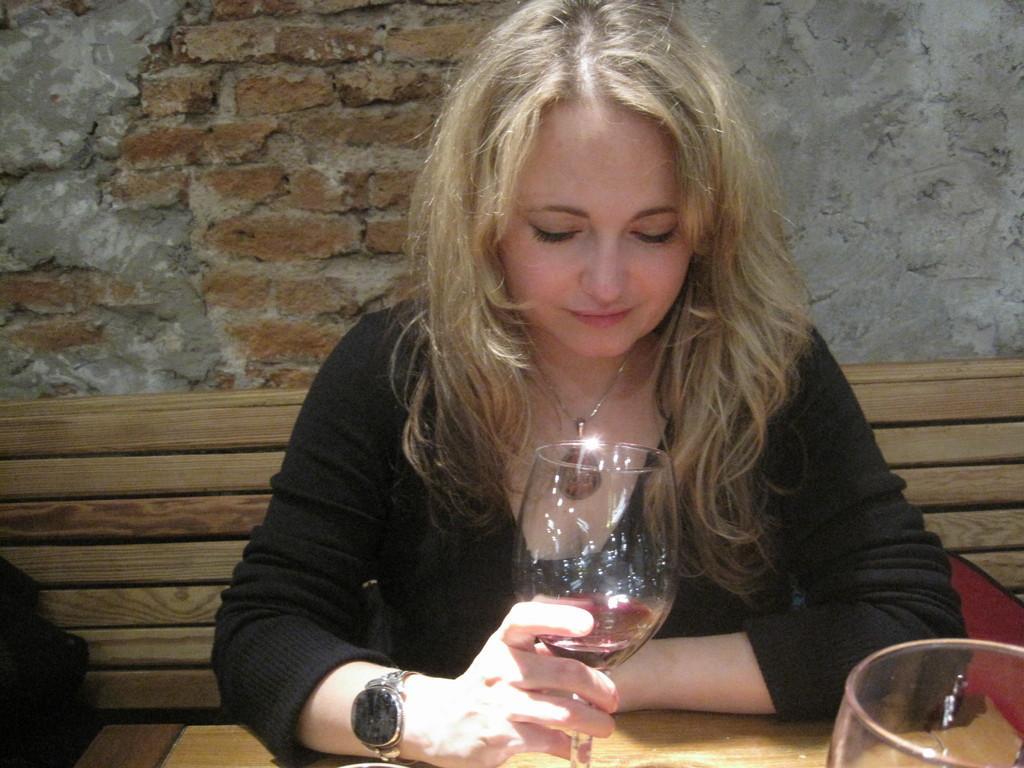In one or two sentences, can you explain what this image depicts? In this picture we can see a woman who is holding a glass with her hand. This is table. On the background there is a wall. 